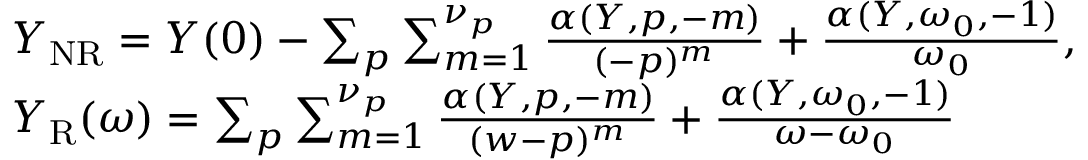Convert formula to latex. <formula><loc_0><loc_0><loc_500><loc_500>\begin{array} { r } { \begin{array} { r l } & { Y _ { N R } = Y ( 0 ) - \sum _ { p } \sum _ { m = 1 } ^ { \nu _ { p } } \frac { \alpha ( Y , p , - m ) } { ( - p ) ^ { m } } + \frac { \alpha ( Y , \omega _ { 0 } , - 1 ) } { \omega _ { 0 } } , } \\ & { Y _ { R } ( \omega ) = \sum _ { p } \sum _ { m = 1 } ^ { \nu _ { p } } \frac { \alpha ( Y , p , - m ) } { ( w - p ) ^ { m } } + \frac { \alpha ( Y , \omega _ { 0 } , - 1 ) } { \omega - \omega _ { 0 } } } \end{array} } \end{array}</formula> 